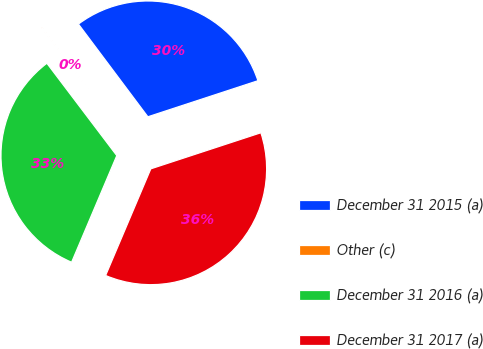Convert chart. <chart><loc_0><loc_0><loc_500><loc_500><pie_chart><fcel>December 31 2015 (a)<fcel>Other (c)<fcel>December 31 2016 (a)<fcel>December 31 2017 (a)<nl><fcel>30.19%<fcel>0.08%<fcel>33.31%<fcel>36.42%<nl></chart> 